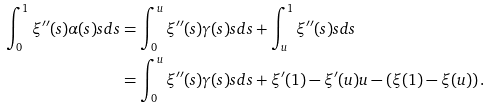Convert formula to latex. <formula><loc_0><loc_0><loc_500><loc_500>\int _ { 0 } ^ { 1 } \xi ^ { \prime \prime } ( s ) \alpha ( s ) s d s & = \int _ { 0 } ^ { u } \xi ^ { \prime \prime } ( s ) \gamma ( s ) s d s + \int _ { u } ^ { 1 } \xi ^ { \prime \prime } ( s ) s d s \\ & = \int _ { 0 } ^ { u } \xi ^ { \prime \prime } ( s ) \gamma ( s ) s d s + \xi ^ { \prime } ( 1 ) - \xi ^ { \prime } ( u ) u - \left ( \xi ( 1 ) - \xi ( u ) \right ) .</formula> 